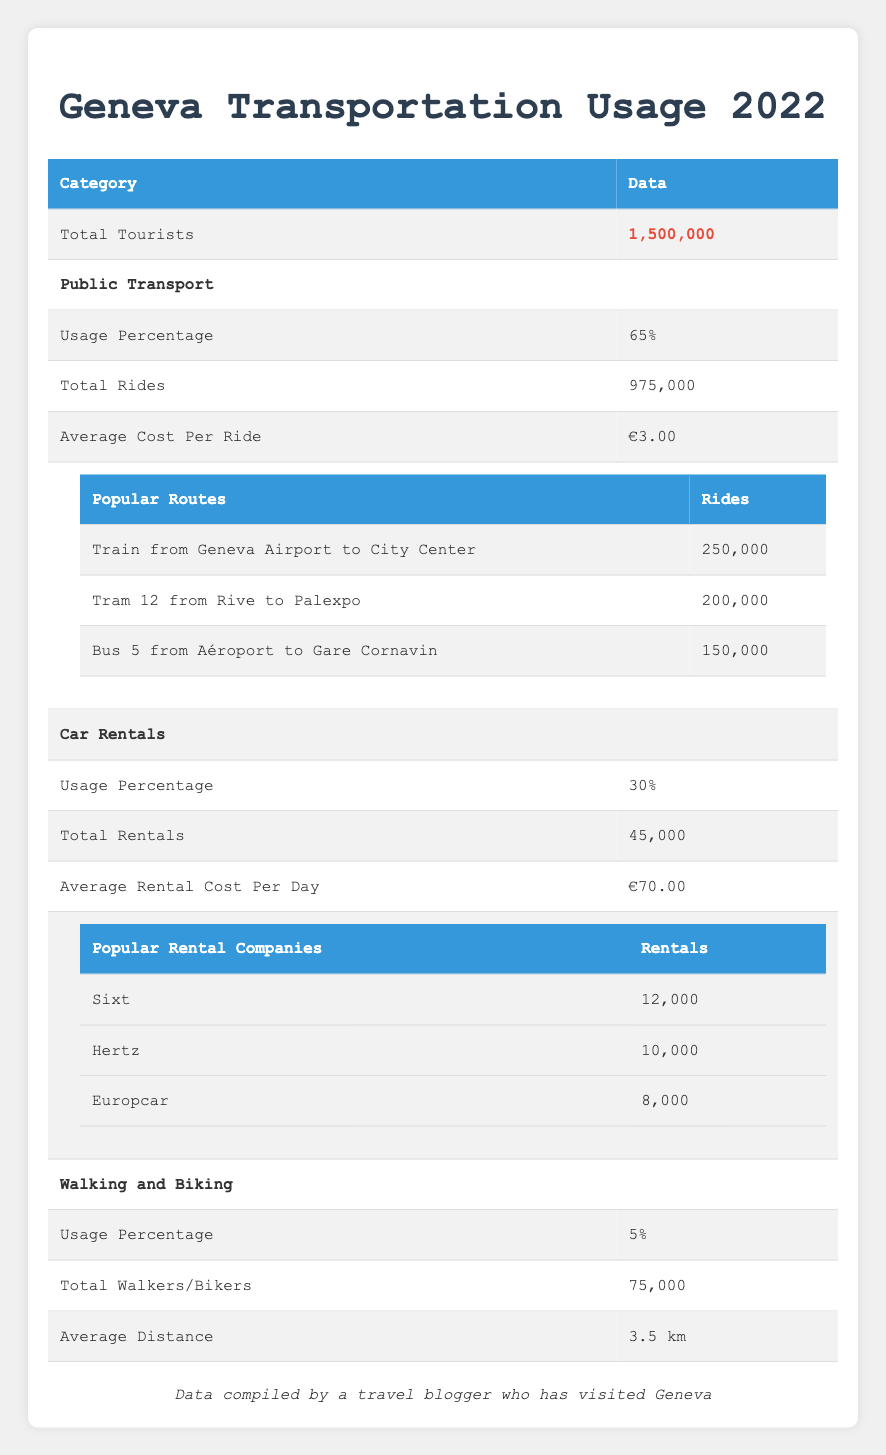What percentage of tourists used public transport in Geneva? According to the table, 65% of total tourists utilized public transport.
Answer: 65% How many total rides were made using public transport? The table states that there were a total of 975,000 rides made using public transport in Geneva.
Answer: 975,000 What is the average cost of a ride on public transport? The table indicates that the average cost per ride for public transport is €3.00.
Answer: €3.00 How many more rentals did Sixt have compared to Europcar? Sixt had 12,000 rentals while Europcar had 8,000 rentals. The difference is calculated as 12,000 - 8,000 = 4,000.
Answer: 4,000 Is it true that more tourists chose public transport over car rentals in Geneva? The public transport usage percentage is 65%, while car rentals are at 30%, which means more tourists chose public transport. Therefore, the statement is true.
Answer: Yes What is the total number of tourists that did not use either public transport or car rentals? The total percentage for public transport and car rentals is 65% + 30% = 95%. Therefore, walking and biking account for 5%. To find the number of tourists who did not use these modes of transport, we calculate 5% of 1,500,000, which is 1,500,000 * 0.05 = 75,000.
Answer: 75,000 Which popular transport route had the highest number of rides? The table lists the popular routes, showing that the "Train from Geneva Airport to City Center" had 250,000 rides, which is the highest compared to the other listed routes.
Answer: Train from Geneva Airport to City Center If the average rental cost per day is €70.00, what would it cost to rent a car for a week? To find the weekly cost, multiply the daily rental cost by 7 days: €70.00 * 7 = €490.00.
Answer: €490.00 What is the average distance traveled by walkers and bikers? The table specifies that the average distance for walkers and bikers is 3.5 km.
Answer: 3.5 km 